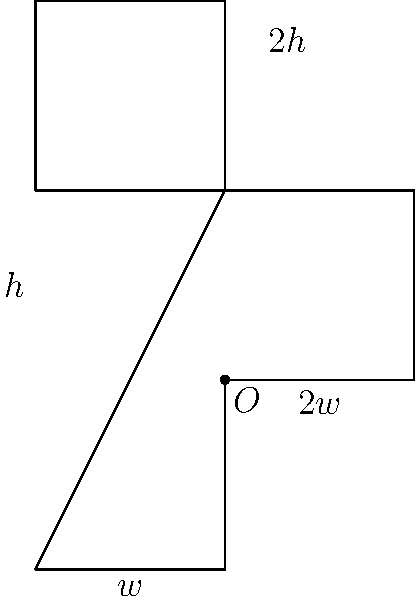A church wants to install a cross-shaped window to maximize natural light. The window's shape is formed by two overlapping rectangles, as shown in the figure. The total perimeter of the window is constrained to be 24 units. Find the dimensions $w$ and $h$ that will maximize the area of the window. Let's approach this step-by-step:

1) First, we need to express the area of the window in terms of $w$ and $h$:
   Area $= 5wh$

2) Next, we express the perimeter constraint:
   Perimeter $= 2w + 2h + 2w + 2h + 2w + 2h = 6w + 6h = 24$
   
   This simplifies to: $w + h = 4$

3) We can express $h$ in terms of $w$:
   $h = 4 - w$

4) Now we can express the area solely in terms of $w$:
   Area $= 5w(4-w) = 20w - 5w^2$

5) To find the maximum, we differentiate the area with respect to $w$ and set it to zero:
   $$\frac{dA}{dw} = 20 - 10w = 0$$

6) Solving this equation:
   $20 - 10w = 0$
   $10w = 20$
   $w = 2$

7) We can find $h$ by substituting this value of $w$:
   $h = 4 - w = 4 - 2 = 2$

8) To confirm this is a maximum, we can check the second derivative:
   $$\frac{d^2A}{dw^2} = -10$$
   This is negative, confirming a maximum.

Therefore, the dimensions that maximize the area are $w = 2$ and $h = 2$.
Answer: $w = 2$, $h = 2$ 